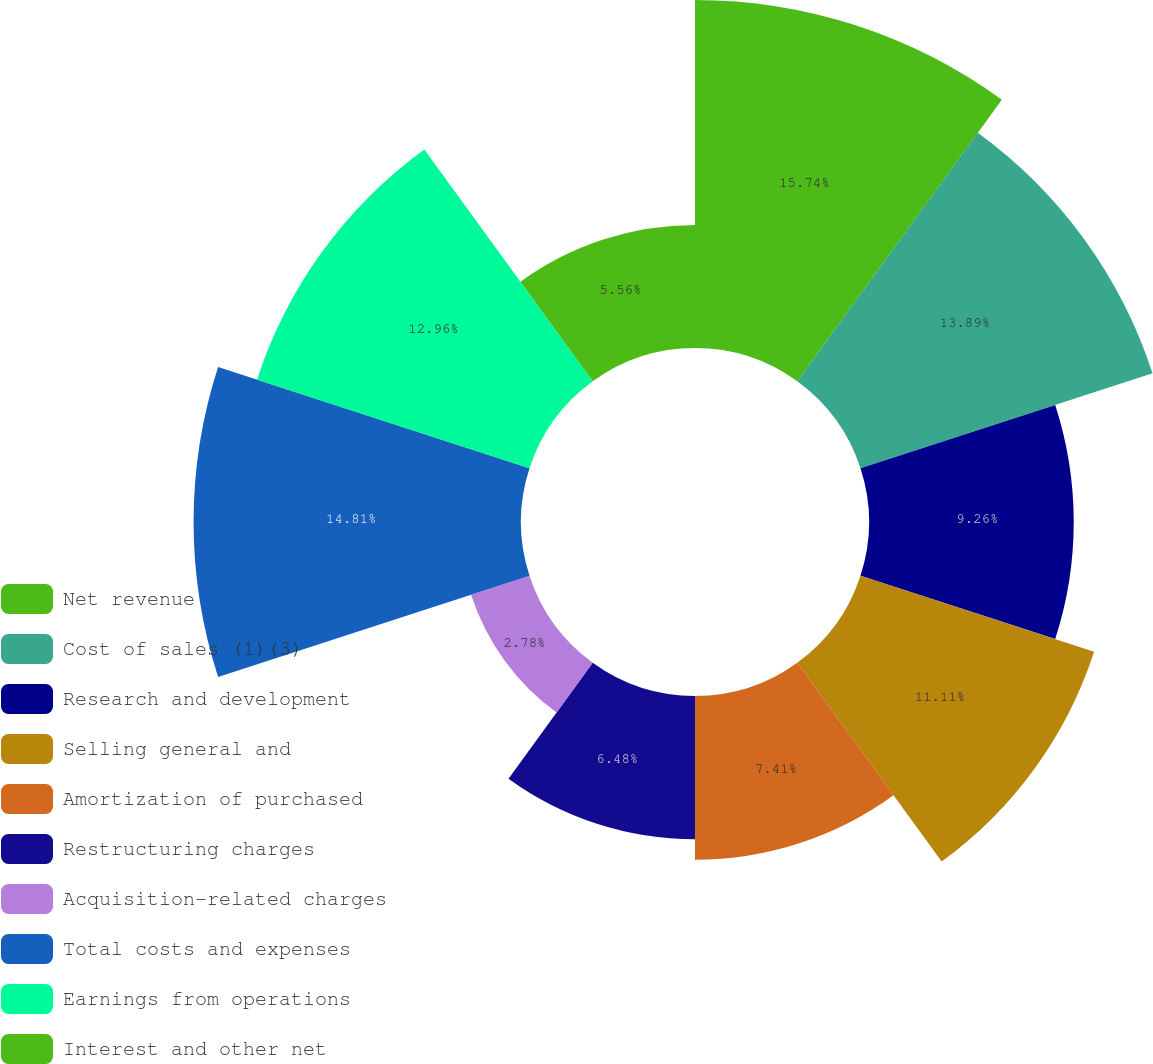<chart> <loc_0><loc_0><loc_500><loc_500><pie_chart><fcel>Net revenue<fcel>Cost of sales (1)(3)<fcel>Research and development<fcel>Selling general and<fcel>Amortization of purchased<fcel>Restructuring charges<fcel>Acquisition-related charges<fcel>Total costs and expenses<fcel>Earnings from operations<fcel>Interest and other net<nl><fcel>15.74%<fcel>13.89%<fcel>9.26%<fcel>11.11%<fcel>7.41%<fcel>6.48%<fcel>2.78%<fcel>14.81%<fcel>12.96%<fcel>5.56%<nl></chart> 